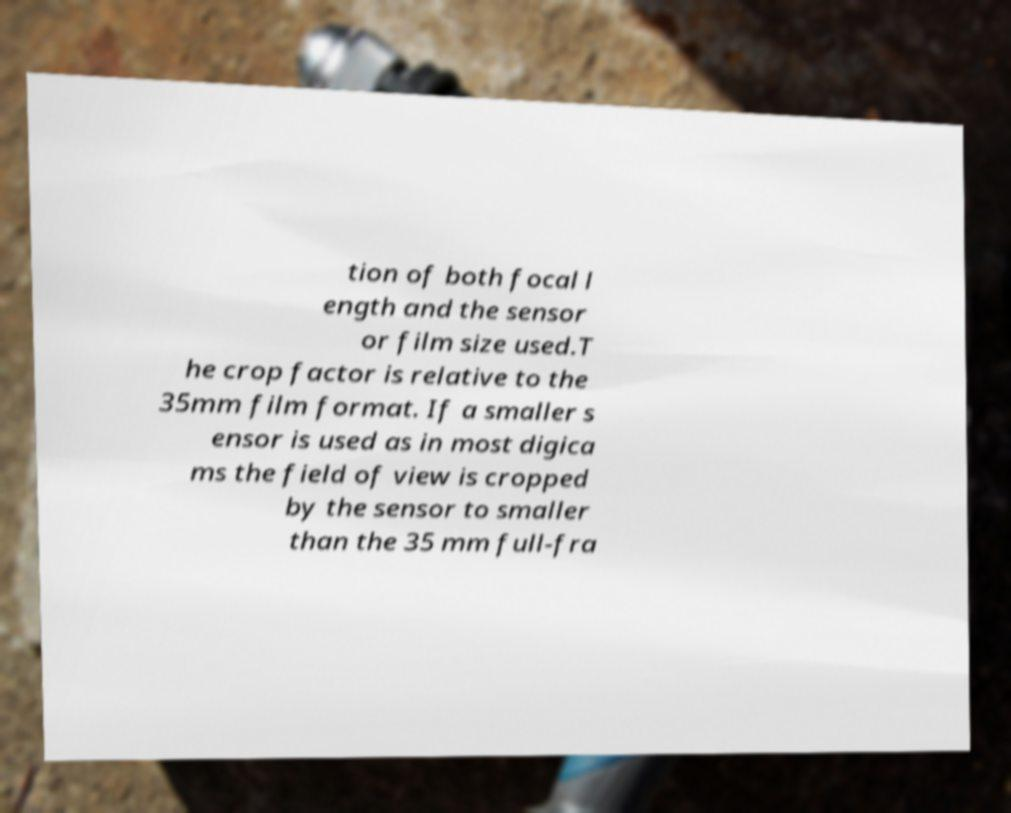There's text embedded in this image that I need extracted. Can you transcribe it verbatim? tion of both focal l ength and the sensor or film size used.T he crop factor is relative to the 35mm film format. If a smaller s ensor is used as in most digica ms the field of view is cropped by the sensor to smaller than the 35 mm full-fra 